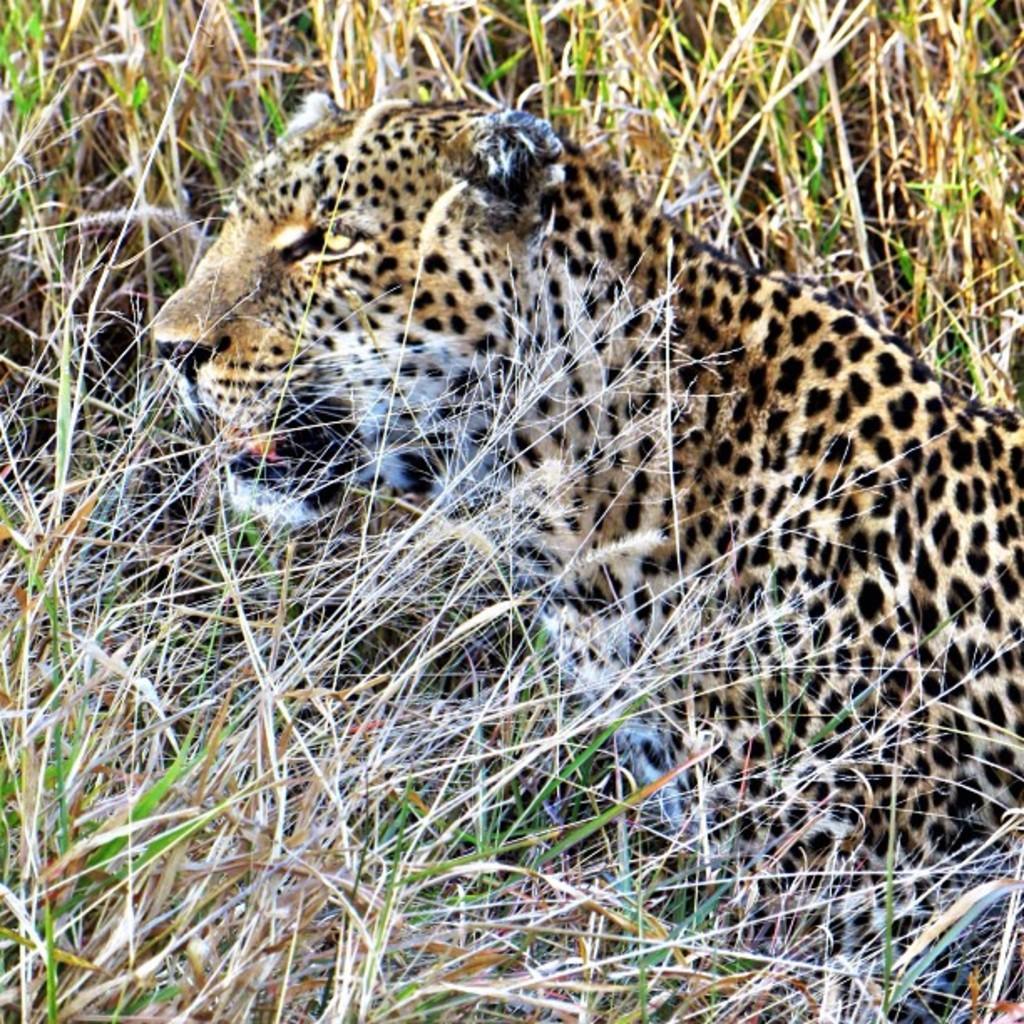Can you describe this image briefly? In this picture we can see a leopard sitting in the field. 